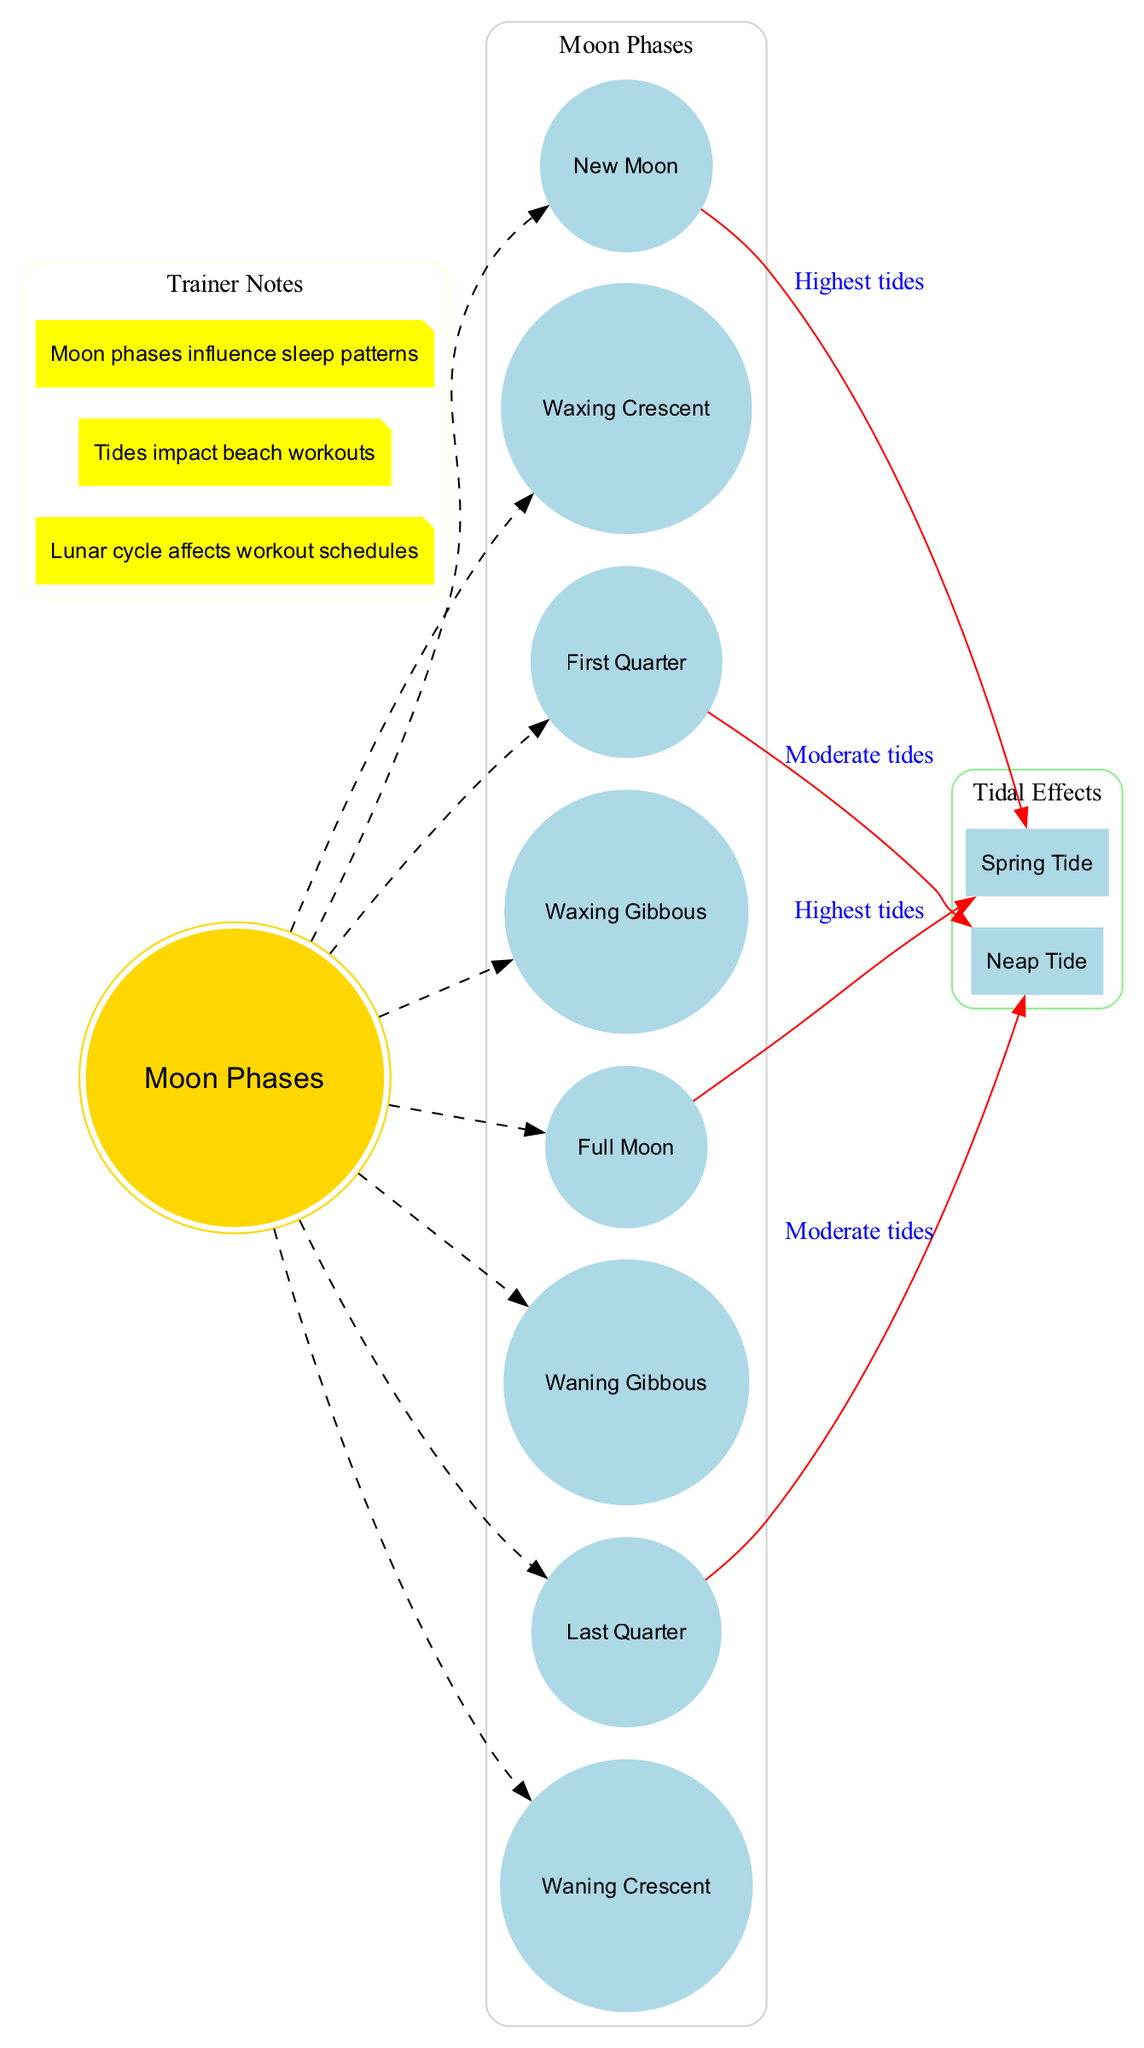What are the eight phases of the Moon? The diagram lists the eight phases of the Moon as follows: New Moon, Waxing Crescent, First Quarter, Waxing Gibbous, Full Moon, Waning Gibbous, Last Quarter, Waning Crescent.
Answer: New Moon, Waxing Crescent, First Quarter, Waxing Gibbous, Full Moon, Waning Gibbous, Last Quarter, Waning Crescent Which two phases are linked to Spring Tide? The connections in the diagram show that New Moon and Full Moon are both associated with Spring Tide, labeled as "Highest tides."
Answer: New Moon, Full Moon What type of tides occur during the First Quarter phase? The connection from First Quarter in the diagram indicates it leads to Neap Tide, which is noted for "Moderate tides."
Answer: Neap Tide How many connections are depicted in the diagram? The diagram illustrates four connections, showing relationships between Moon phases and tidal effects.
Answer: Four What is the effect of the New Moon on tides? The diagram specifies that during the New Moon phase, there is the highest tidal effect labeled as Spring Tide.
Answer: Highest tides What color are the tidal effects represented in the diagram? The diagram shows that the subgraph for tidal effects is colored light green, differentiating it from other sections.
Answer: Light green How do the moon phases affect workout schedules according to trainer notes? The trainer notes indicate that the lunar cycle impacts workout schedules, suggesting an influence based on the phases of the Moon.
Answer: Lunar cycle affects workout schedules Which phase corresponds to Moderate tides? The diagram connects both the First Quarter and Last Quarter phases to Neap Tide, categorized as Moderate tides.
Answer: First Quarter, Last Quarter 